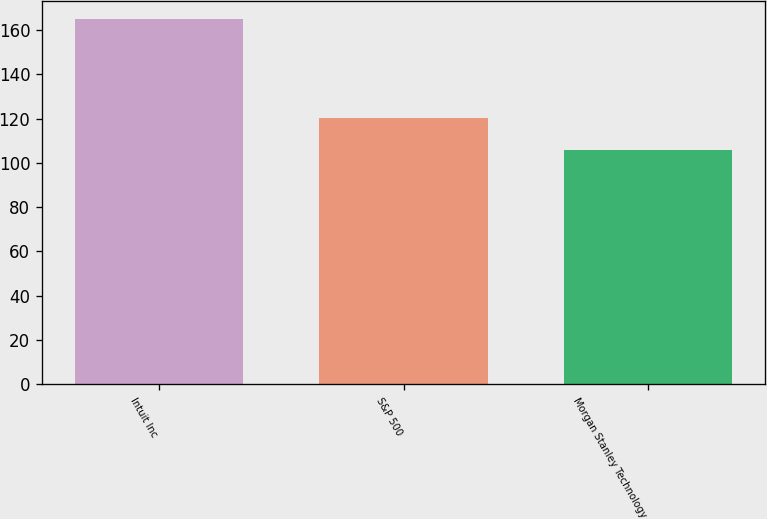Convert chart to OTSL. <chart><loc_0><loc_0><loc_500><loc_500><bar_chart><fcel>Intuit Inc<fcel>S&P 500<fcel>Morgan Stanley Technology<nl><fcel>164.9<fcel>120.19<fcel>106.05<nl></chart> 